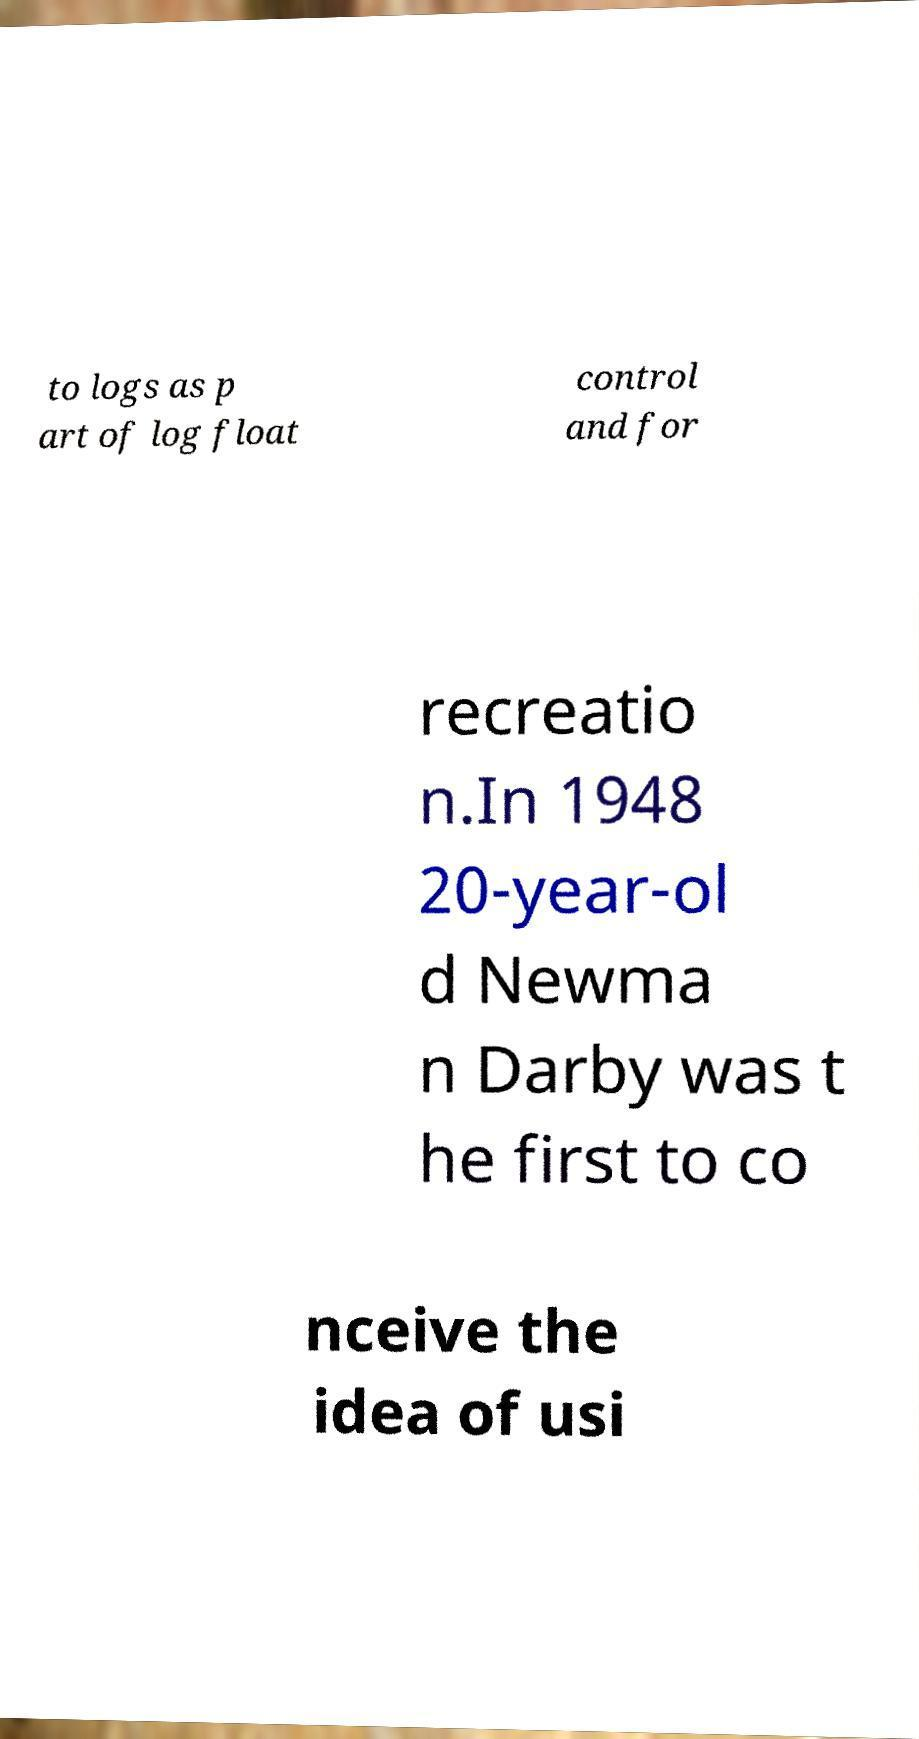There's text embedded in this image that I need extracted. Can you transcribe it verbatim? to logs as p art of log float control and for recreatio n.In 1948 20-year-ol d Newma n Darby was t he first to co nceive the idea of usi 